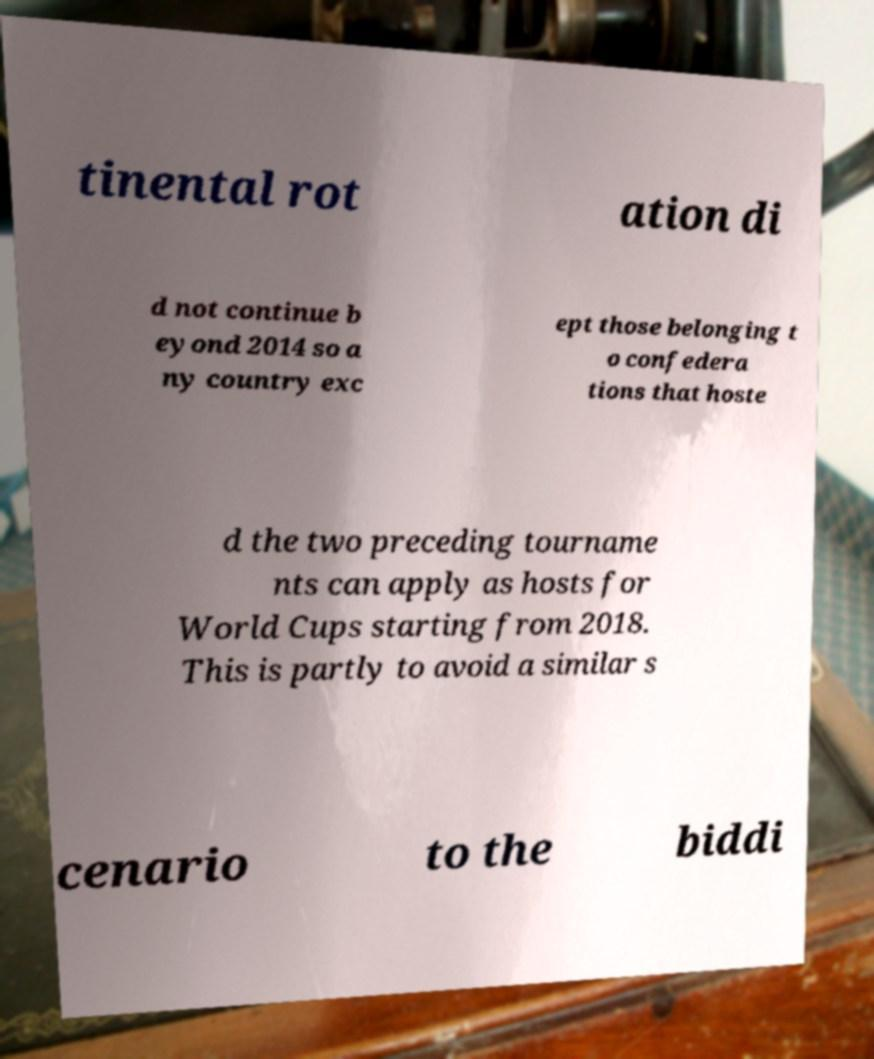Could you assist in decoding the text presented in this image and type it out clearly? tinental rot ation di d not continue b eyond 2014 so a ny country exc ept those belonging t o confedera tions that hoste d the two preceding tourname nts can apply as hosts for World Cups starting from 2018. This is partly to avoid a similar s cenario to the biddi 